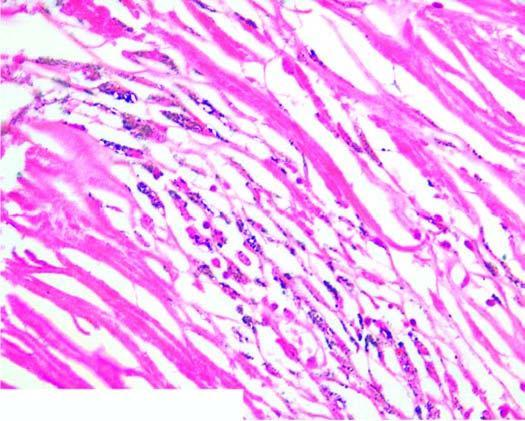does iron consist of hyaline centre surrounded by concentric layers of collagen which are further enclosed by fibroblasts and dust-laden macrophages?
Answer the question using a single word or phrase. No 